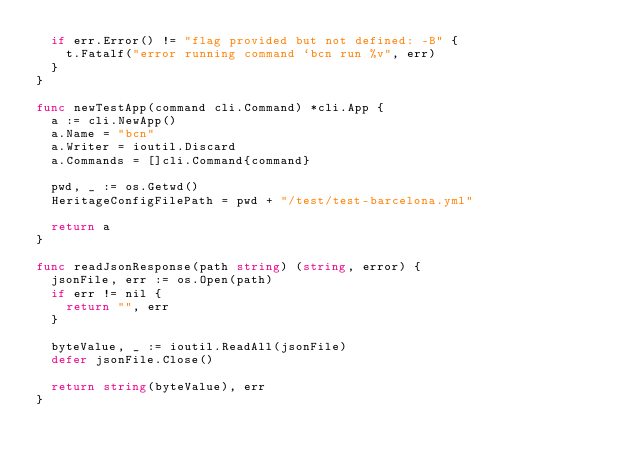<code> <loc_0><loc_0><loc_500><loc_500><_Go_>	if err.Error() != "flag provided but not defined: -B" {
		t.Fatalf("error running command `bcn run %v", err)
	}
}

func newTestApp(command cli.Command) *cli.App {
	a := cli.NewApp()
	a.Name = "bcn"
	a.Writer = ioutil.Discard
	a.Commands = []cli.Command{command}

	pwd, _ := os.Getwd()
	HeritageConfigFilePath = pwd + "/test/test-barcelona.yml"

	return a
}

func readJsonResponse(path string) (string, error) {
	jsonFile, err := os.Open(path)
	if err != nil {
		return "", err
	}

	byteValue, _ := ioutil.ReadAll(jsonFile)
	defer jsonFile.Close()

	return string(byteValue), err
}
</code> 